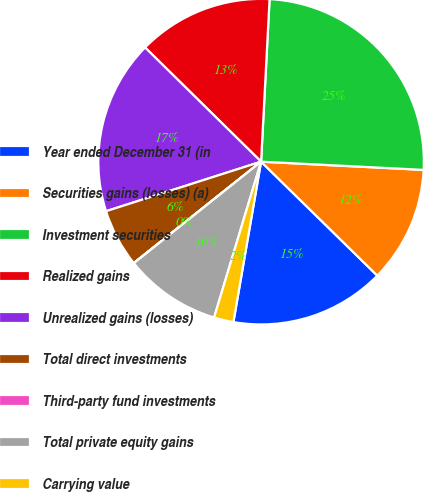<chart> <loc_0><loc_0><loc_500><loc_500><pie_chart><fcel>Year ended December 31 (in<fcel>Securities gains (losses) (a)<fcel>Investment securities<fcel>Realized gains<fcel>Unrealized gains (losses)<fcel>Total direct investments<fcel>Third-party fund investments<fcel>Total private equity gains<fcel>Carrying value<nl><fcel>15.38%<fcel>11.54%<fcel>24.98%<fcel>13.46%<fcel>17.3%<fcel>5.78%<fcel>0.02%<fcel>9.62%<fcel>1.94%<nl></chart> 